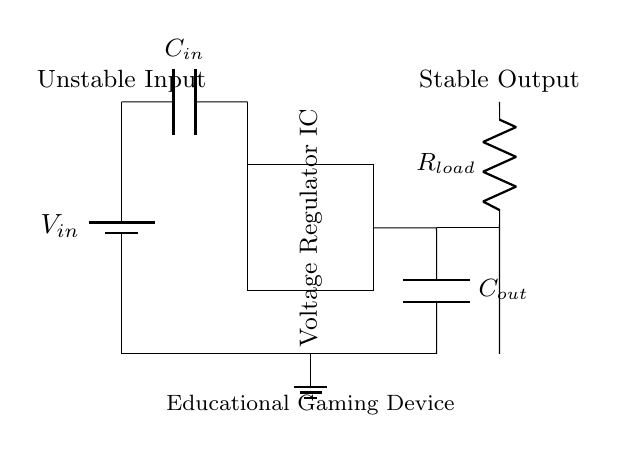What is the type of regulator in this circuit? The circuit contains a voltage regulator IC, which is identified by the rectangular block labeled as such.
Answer: Voltage regulator IC What is the purpose of the input capacitor? The input capacitor helps to stabilize the voltage supplied to the regulator by filtering out any noise or fluctuations in the input voltage.
Answer: Stabilization What component is used to represent the load in the circuit? The load is represented by a resistor labeled as R load, which is indicated in the output section of the circuit.
Answer: R load How many capacitors are present in the circuit? There are two capacitors: one is C in at the input, and the other is C out at the output, as shown in the circuit diagram.
Answer: Two What is the relationship between input voltage and output voltage in a voltage regulator circuit? The voltage regulator is designed to maintain a stable output voltage regardless of variations in the input voltage, effectively providing a regulated output.
Answer: Stable output What is connected to the ground in the circuit? The ground connection is made at the bottom of the circuit where the negative terminal of the battery and other components converge, ensuring a common reference point for voltage levels.
Answer: Ground 